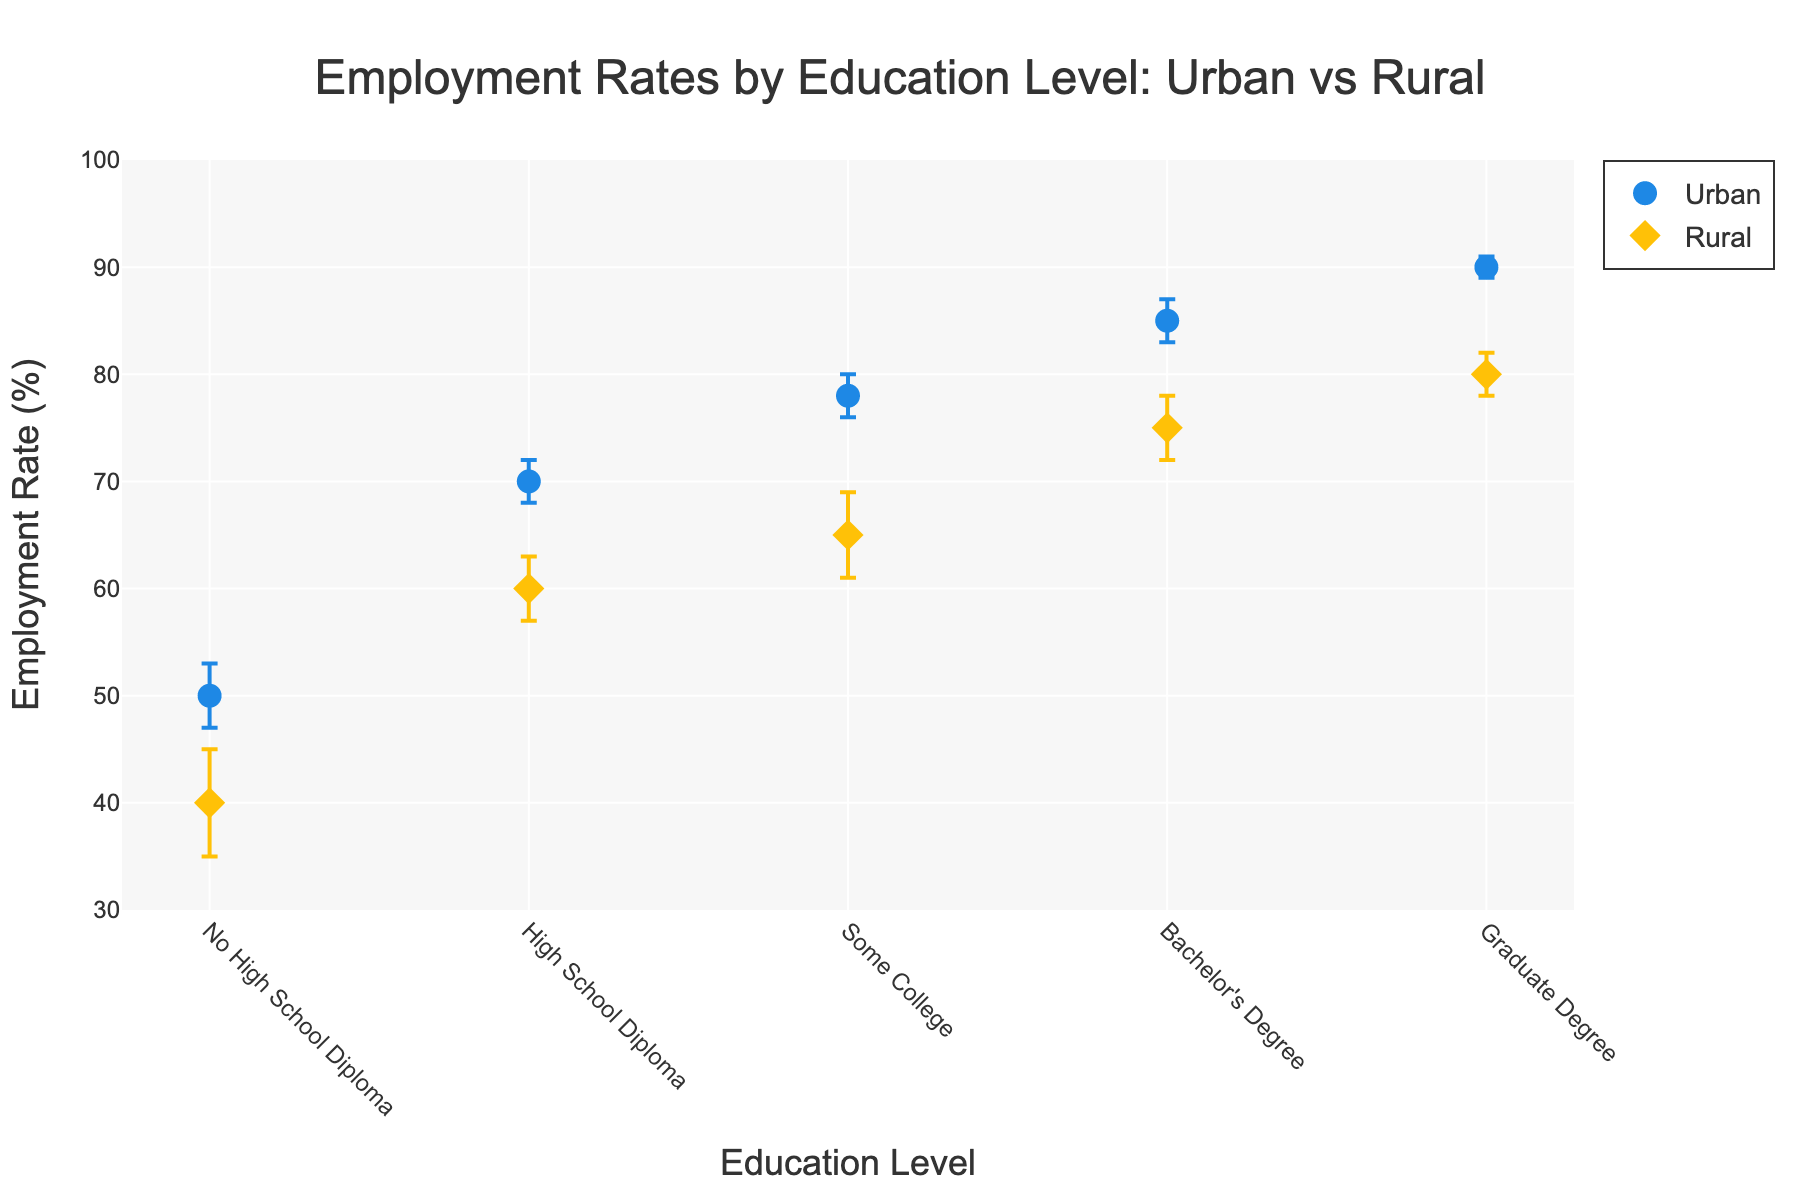What's the title of the plot? The title of the plot is located at the top center of the plot and is presented in large font.
Answer: Employment Rates by Education Level: Urban vs Rural What is the employment rate for individuals with a graduate degree in rural areas? Look at the data point marked with a diamond symbol on the x-axis labeled "Graduate Degree" under the 'Rural' section.
Answer: 80% Which education level has the largest difference in employment rates between urban and rural areas? Compare the differences between employment rates for each education level by subtracting rural rates from urban rates. The largest numerical difference is 15% for the "Some College" category (78% - 65%).
Answer: Some College For which education level is the error margin the smallest? Identify the smallest error bars in both urban and rural data points. The smallest error margin is 1% for the "Graduate Degree" in the urban area.
Answer: Graduate Degree (Urban) What is the average employment rate for urban areas across all education levels? Add up all urban employment rates (50 + 70 + 78 + 85 + 90) and divide by the number of education levels (5). (50 + 70 + 78 + 85 + 90) / 5 = 373 / 5 = 74.6%
Answer: 74.6% Is there an education level where the employment rate is equal between urban and rural areas? Compare the employment rates for each education level to see if they match precisely. They do not match for any education level.
Answer: No How does the employment rate for individuals with a high school diploma compare between urban and rural areas? Compare the two rates directly: Urban (70%) and Rural (60%). The urban rate is higher by 10%.
Answer: Urban rate is 10% higher Which area, urban or rural, has consistently lower employment rates across all levels of education? Check the markers for each education level, comparing urban and rural areas. Rural areas consistently show lower employment rates across all education levels.
Answer: Rural What is the range of employment rates for rural areas? Find the minimum and maximum employment rates in rural areas. The minimum is 40% (No High School Diploma) and the maximum is 80% (Graduate Degree). Range = 80% - 40% = 40%.
Answer: 40% What is the employment rate difference for those with no high school diploma between urban and rural regions? The employment rates for those with no high school diploma are 50% (Urban) and 40% (Rural). The difference is 50% - 40% = 10%.
Answer: 10% 